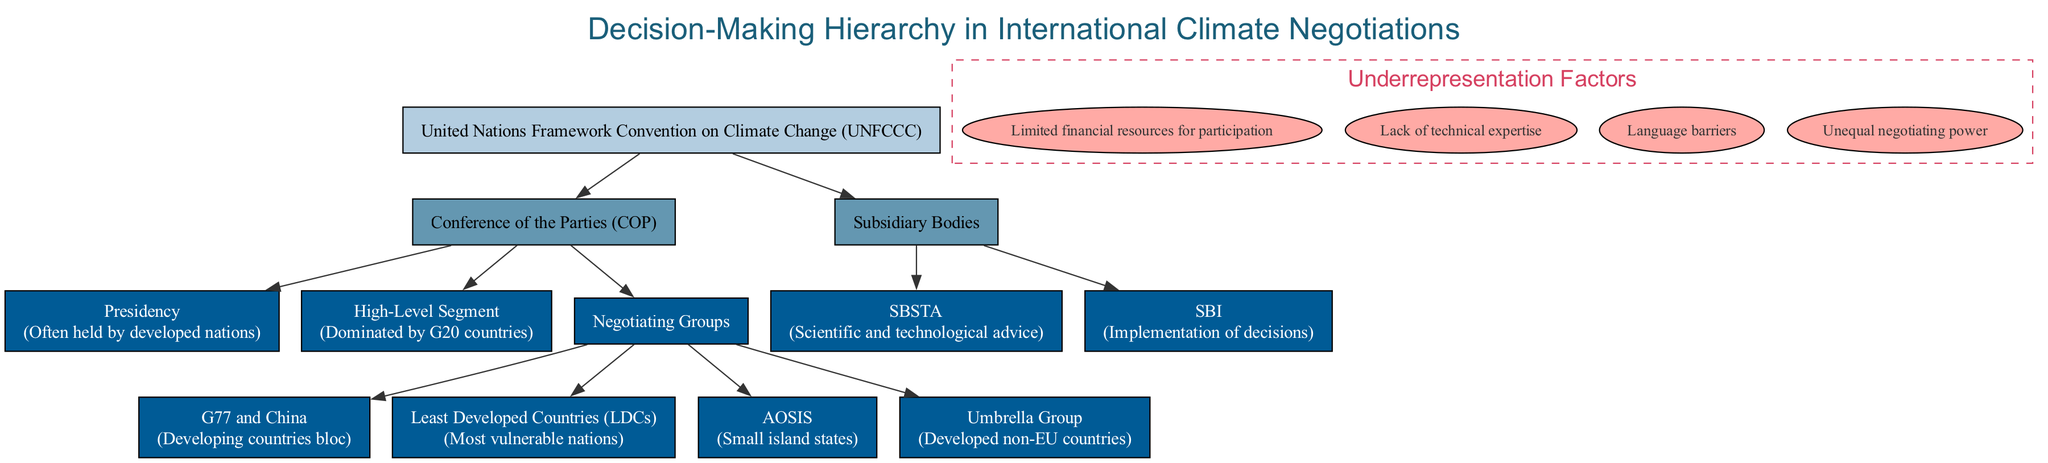What is the top level of the decision-making hierarchy? The top level in the diagram is the United Nations Framework Convention on Climate Change (UNFCCC). This can be identified as it is the first node mentioned in the hierarchy.
Answer: United Nations Framework Convention on Climate Change (UNFCCC) How many negotiating groups are present under the Conference of the Parties? The diagram shows four negotiating groups: G77 and China, Least Developed Countries (LDCs), AOSIS, and Umbrella Group. Counting these groups reveals a total of four.
Answer: 4 Which party traditionally holds the presidency? In the diagram, it is stated that the presidency is often held by developed nations, indicating that this position is not typically held by developing nations.
Answer: Developed nations What is the role of the SBSTA? The diagram describes SBSTA as providing scientific and technological advice, which outlines its function within the subsidiary bodies of the decision-making hierarchy.
Answer: Scientific and technological advice What color represents the top level in the diagram? In the diagram, the top level (UNFCCC) is represented by the color #b3cde0, which is specified as the color attributed to nodes at depth zero.
Answer: #b3cde0 Name one factor contributing to the underrepresentation of developing nations. The diagram lists several factors, and one of them is "Limited financial resources for participation," which reflects challenges faced by developing nations in contributing to climate negotiations.
Answer: Limited financial resources for participation Which group is identified as the bloc of developing countries? The diagram clearly indicates that the G77 and China is the bloc that represents developing countries within the negotiating groups.
Answer: G77 and China In the hierarchy, which segment is dominated by G20 countries? The High-Level Segment is mentioned in the diagram as being dominated by G20 countries, illustrating a significant influence of this group in negotiations.
Answer: High-Level Segment How is the Umbrella Group characterized in the diagram? The diagram characterizes the Umbrella Group as representing developed non-EU countries, which helps to understand its composition and role in negotiations.
Answer: Developed non-EU countries 